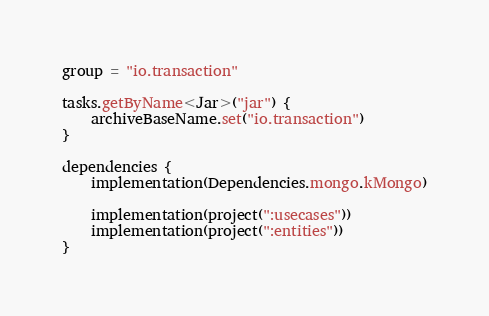Convert code to text. <code><loc_0><loc_0><loc_500><loc_500><_Kotlin_>group = "io.transaction"

tasks.getByName<Jar>("jar") {
    archiveBaseName.set("io.transaction")
}

dependencies {
    implementation(Dependencies.mongo.kMongo)

    implementation(project(":usecases"))
    implementation(project(":entities"))
}
</code> 